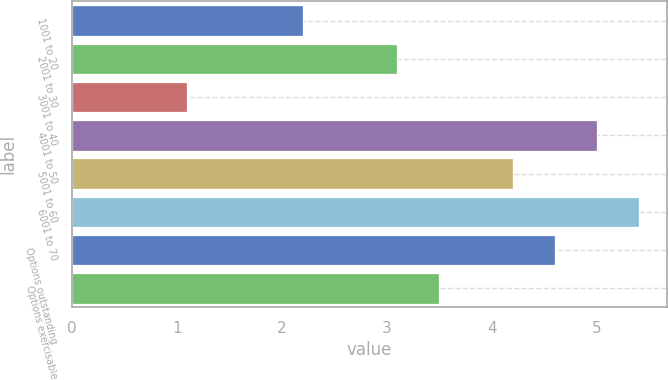Convert chart. <chart><loc_0><loc_0><loc_500><loc_500><bar_chart><fcel>1001 to 20<fcel>2001 to 30<fcel>3001 to 40<fcel>4001 to 50<fcel>5001 to 60<fcel>6001 to 70<fcel>Options outstanding<fcel>Options exercisable<nl><fcel>2.2<fcel>3.1<fcel>1.1<fcel>5<fcel>4.2<fcel>5.4<fcel>4.6<fcel>3.5<nl></chart> 